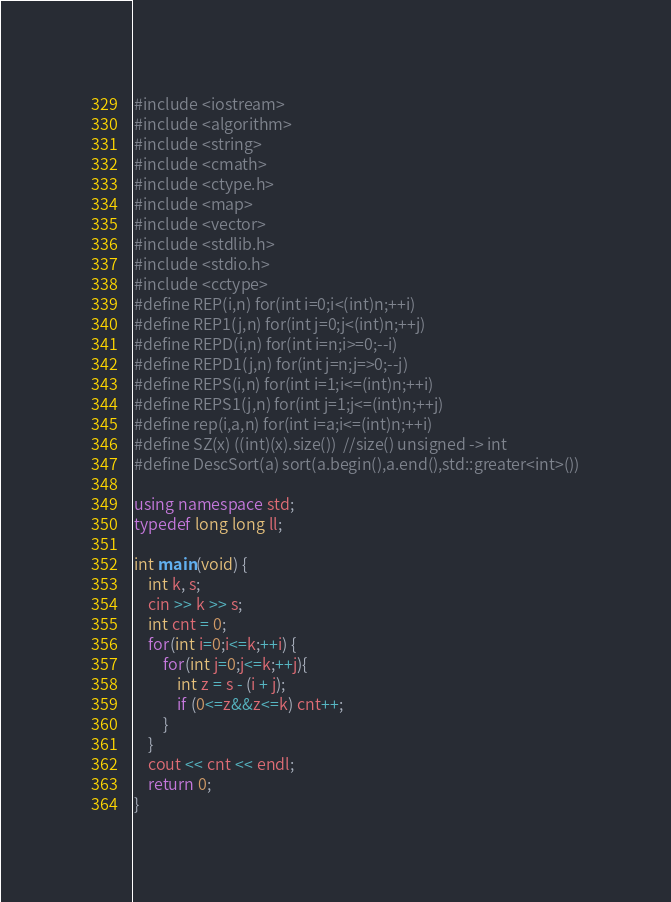Convert code to text. <code><loc_0><loc_0><loc_500><loc_500><_C++_>#include <iostream>
#include <algorithm>
#include <string>
#include <cmath>
#include <ctype.h>
#include <map>
#include <vector>
#include <stdlib.h>
#include <stdio.h>
#include <cctype>
#define REP(i,n) for(int i=0;i<(int)n;++i)
#define REP1(j,n) for(int j=0;j<(int)n;++j)
#define REPD(i,n) for(int i=n;i>=0;--i)
#define REPD1(j,n) for(int j=n;j=>0;--j)
#define REPS(i,n) for(int i=1;i<=(int)n;++i)
#define REPS1(j,n) for(int j=1;j<=(int)n;++j)
#define rep(i,a,n) for(int i=a;i<=(int)n;++i)
#define SZ(x) ((int)(x).size())	//size() unsigned -> int
#define DescSort(a) sort(a.begin(),a.end(),std::greater<int>())

using namespace std;
typedef long long ll;

int main(void) {
	int k, s;
	cin >> k >> s;
	int cnt = 0;
	for(int i=0;i<=k;++i) {
		for(int j=0;j<=k;++j){
			int z = s - (i + j);
			if (0<=z&&z<=k) cnt++;
		}
	}
	cout << cnt << endl;
	return 0;
}

</code> 